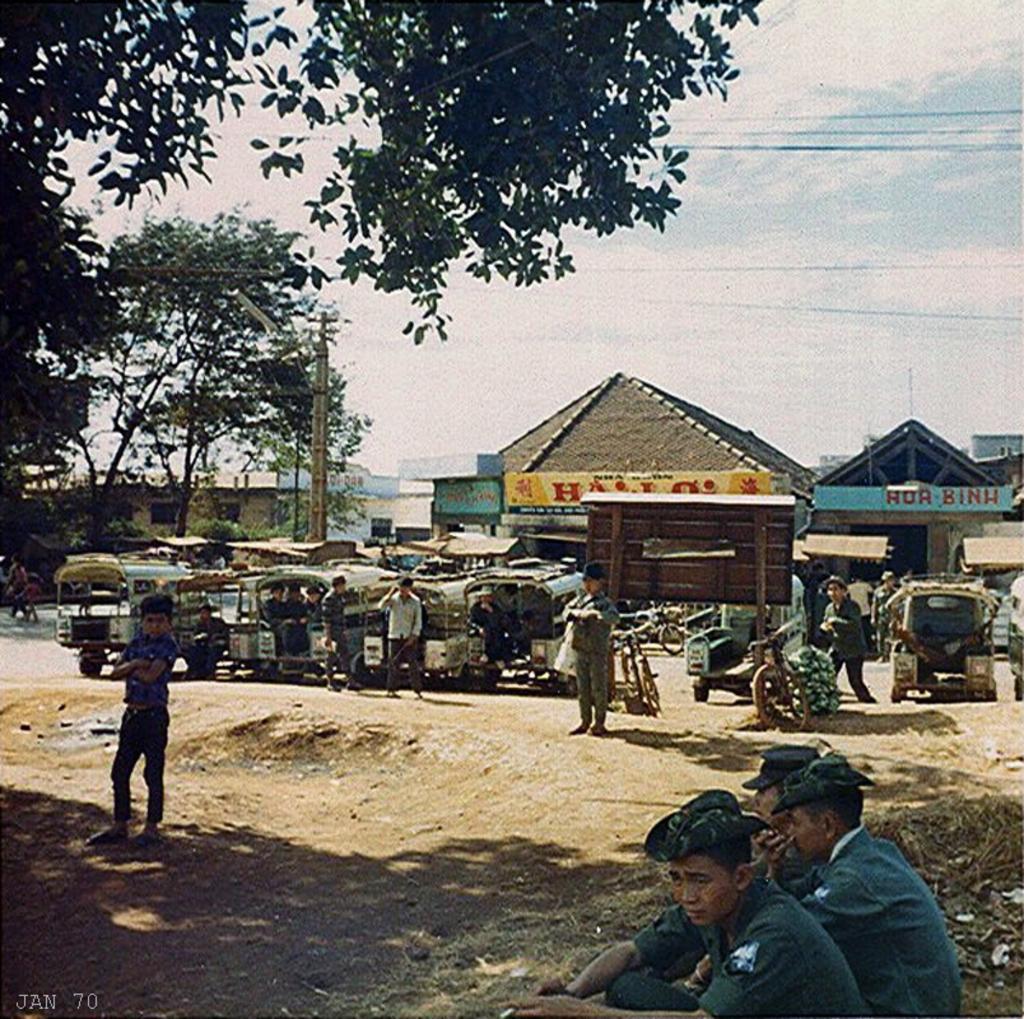Could you give a brief overview of what you see in this image? In this image there are group of persons and some vehicles. In the background there are some houses, poles, trees, wires and at the bottom there is sand and walkway and some persons are sitting. At the top of the image there is sky. 